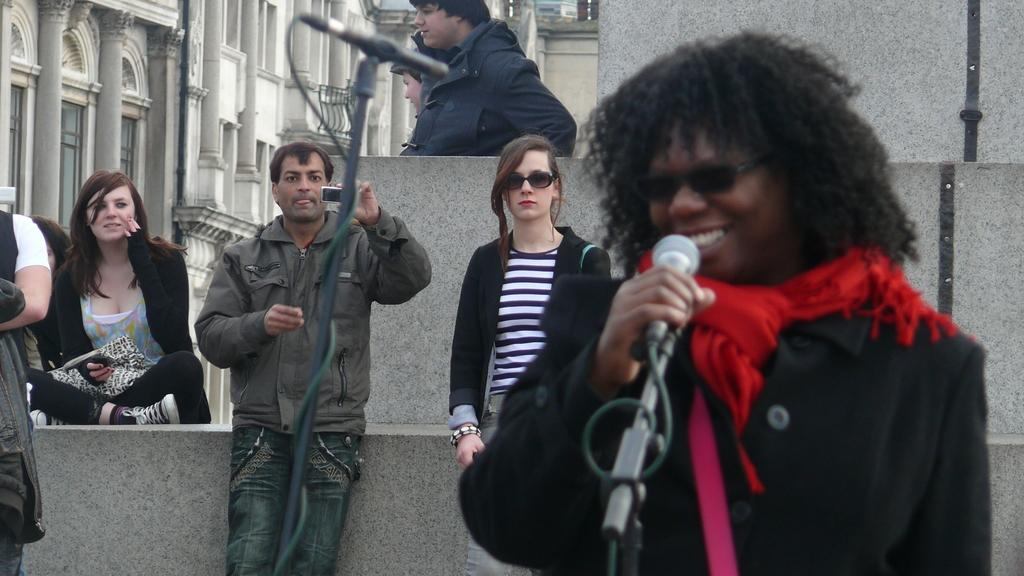What is the person in the image doing? There is a person singing on a mic in the image. Are there any other people present in the image? Yes, there are people behind the singer. What is the purpose of the camera in the image? Someone is recording the performance on a camera. What is the singer holding to amplify their voice? There is a mic with a stand in the image. What can be seen in the background of the image? There are buildings visible in the image. Can you see any quivers in the image? There are no quivers present in the image. Are there any fangs visible on the singer? There are no fangs visible on the singer in the image. 